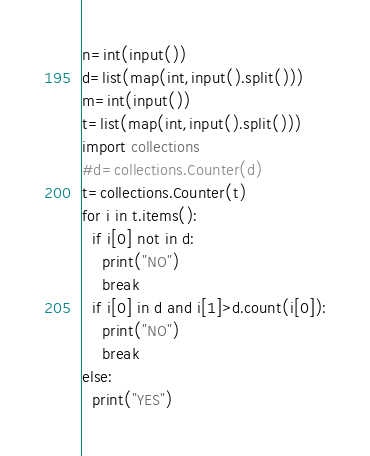Convert code to text. <code><loc_0><loc_0><loc_500><loc_500><_Python_>n=int(input())
d=list(map(int,input().split()))
m=int(input())
t=list(map(int,input().split()))
import collections
#d=collections.Counter(d)
t=collections.Counter(t)
for i in t.items():
  if i[0] not in d:
    print("NO")
    break
  if i[0] in d and i[1]>d.count(i[0]):
    print("NO")
    break
else:
  print("YES")
</code> 